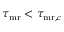Convert formula to latex. <formula><loc_0><loc_0><loc_500><loc_500>\tau _ { m r } < \tau _ { { m r } , c }</formula> 